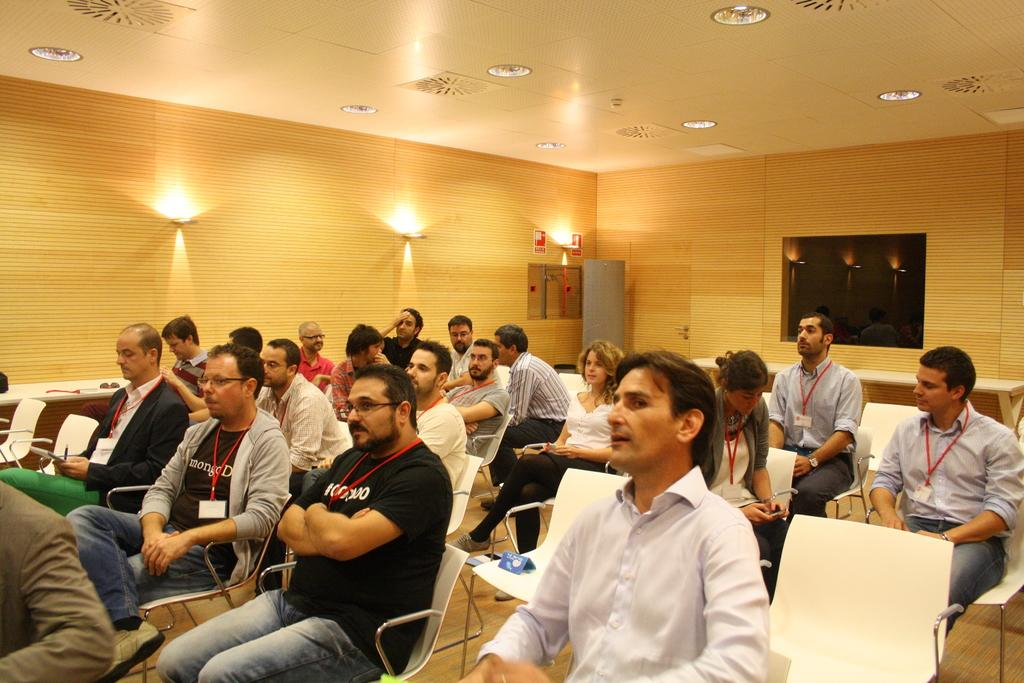What part of the room can be seen in the image? The ceiling is visible in the image. What can be found on the left side of the image? There are lights on the left side of the image. What are the people in the image doing? People are sitting on chairs in the image. What time is displayed on the clock in the image? There is no clock present in the image. What act are the people performing while sitting on the chairs? There is no act being performed by the people sitting on the chairs; they are simply sitting. 